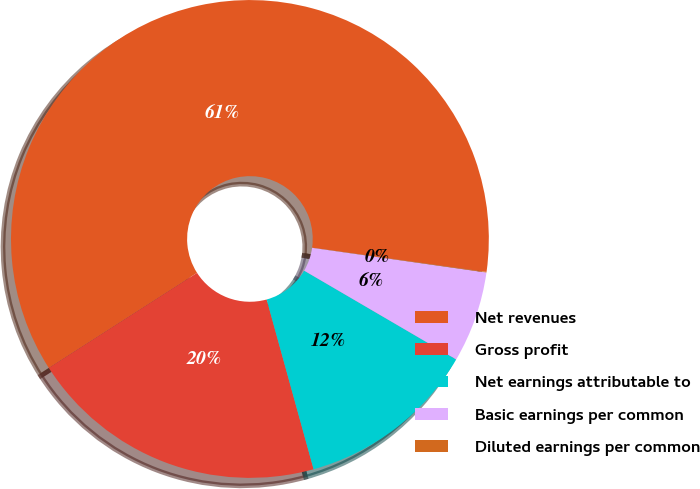<chart> <loc_0><loc_0><loc_500><loc_500><pie_chart><fcel>Net revenues<fcel>Gross profit<fcel>Net earnings attributable to<fcel>Basic earnings per common<fcel>Diluted earnings per common<nl><fcel>61.27%<fcel>20.22%<fcel>12.29%<fcel>6.17%<fcel>0.04%<nl></chart> 